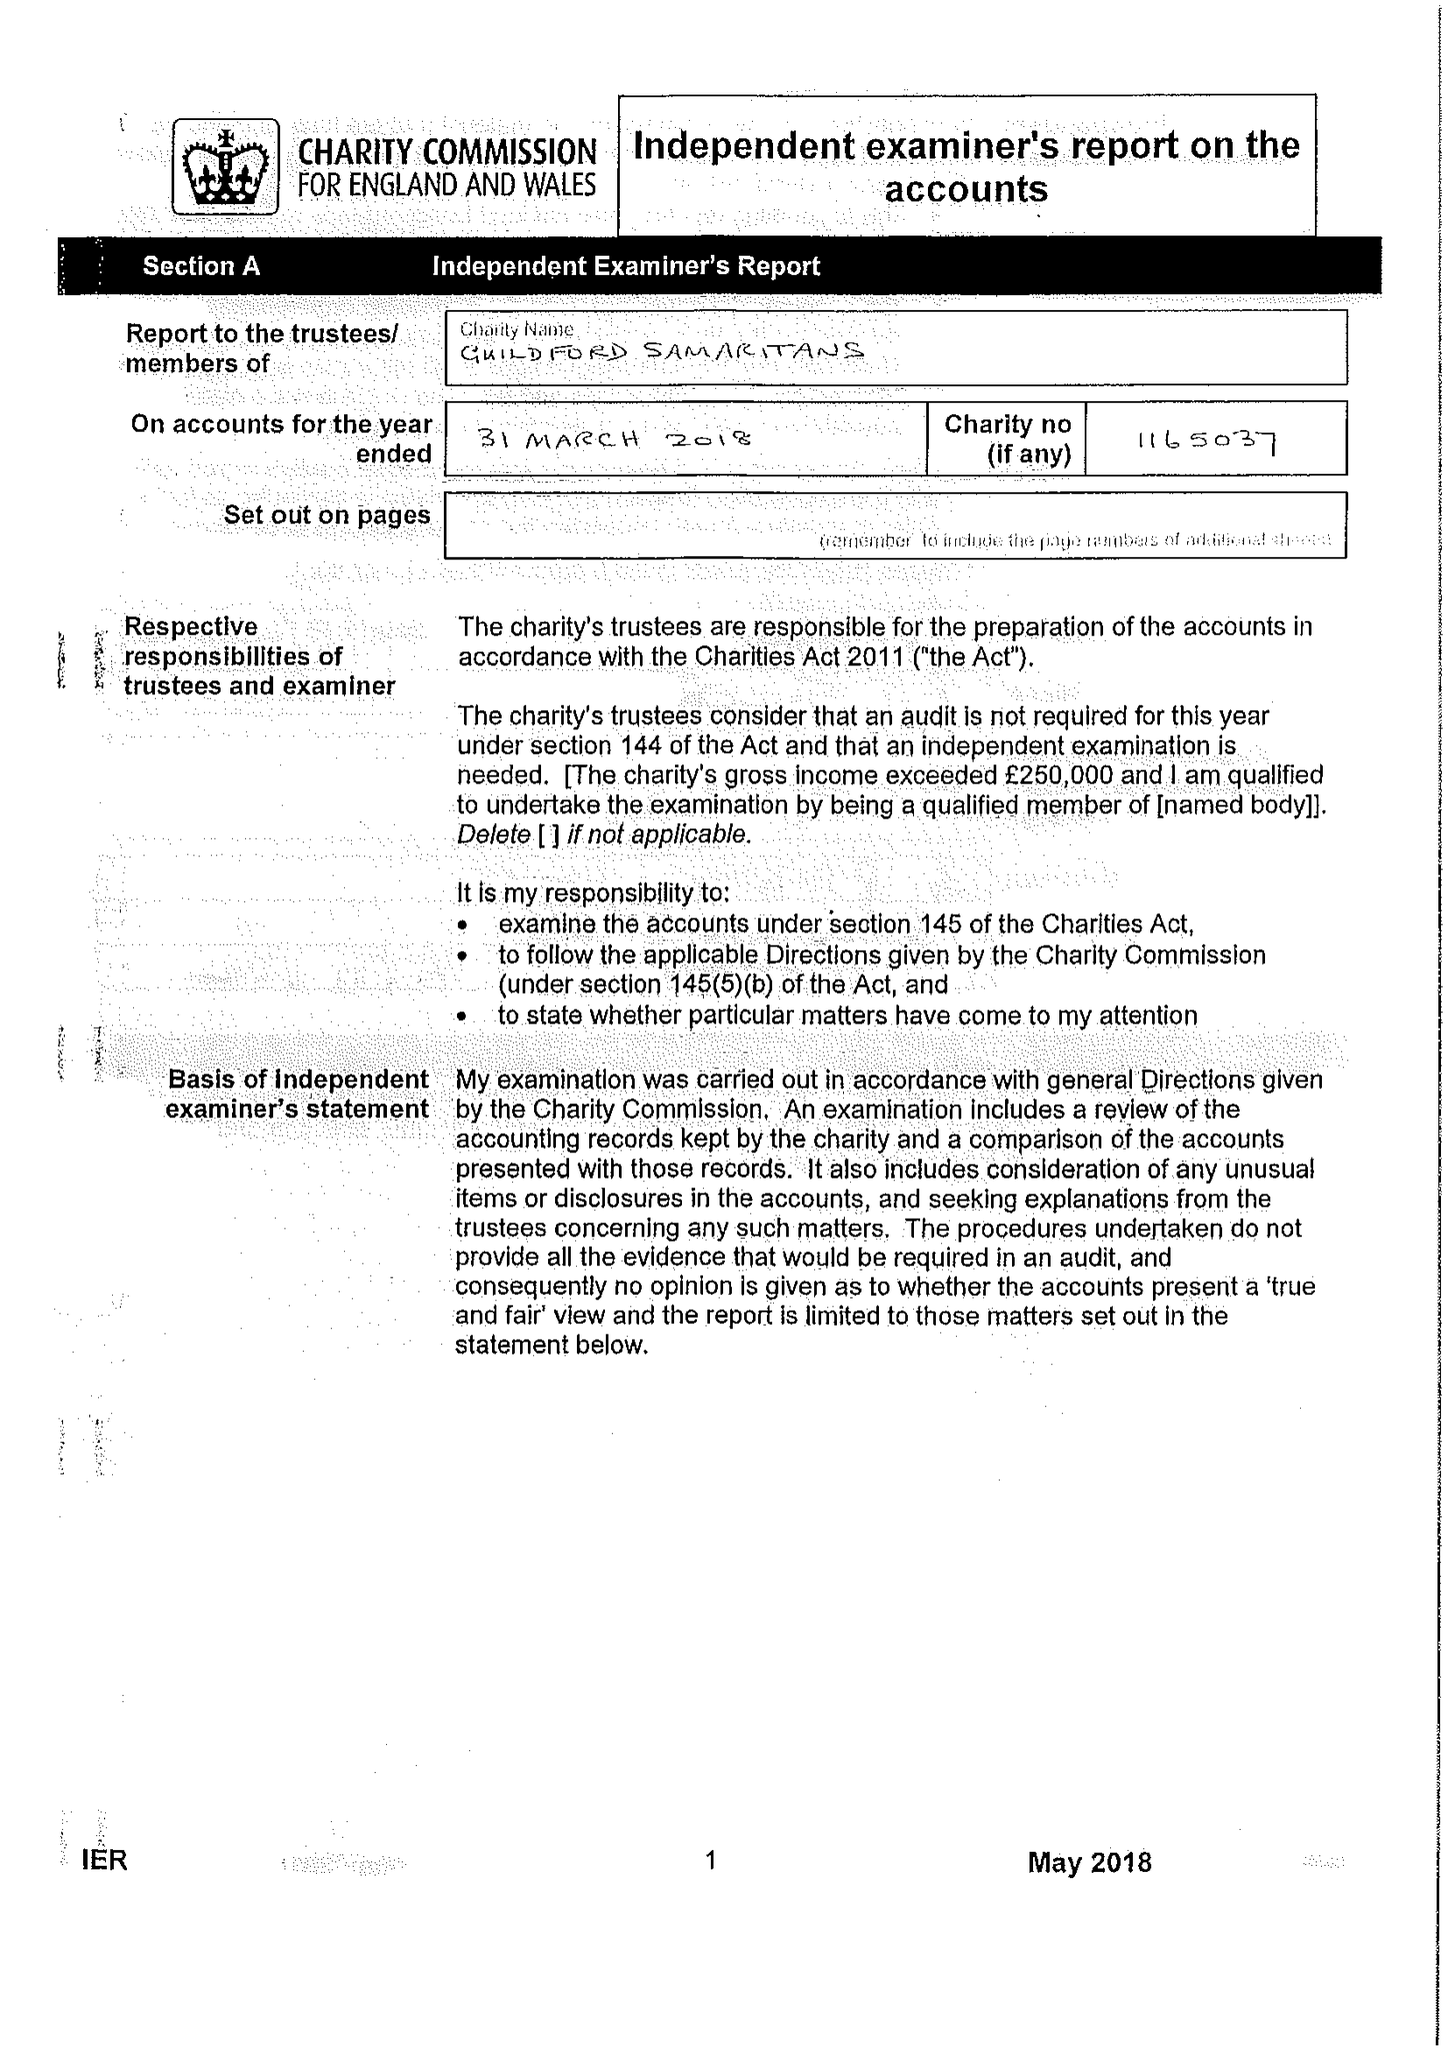What is the value for the report_date?
Answer the question using a single word or phrase. 2018-03-31 